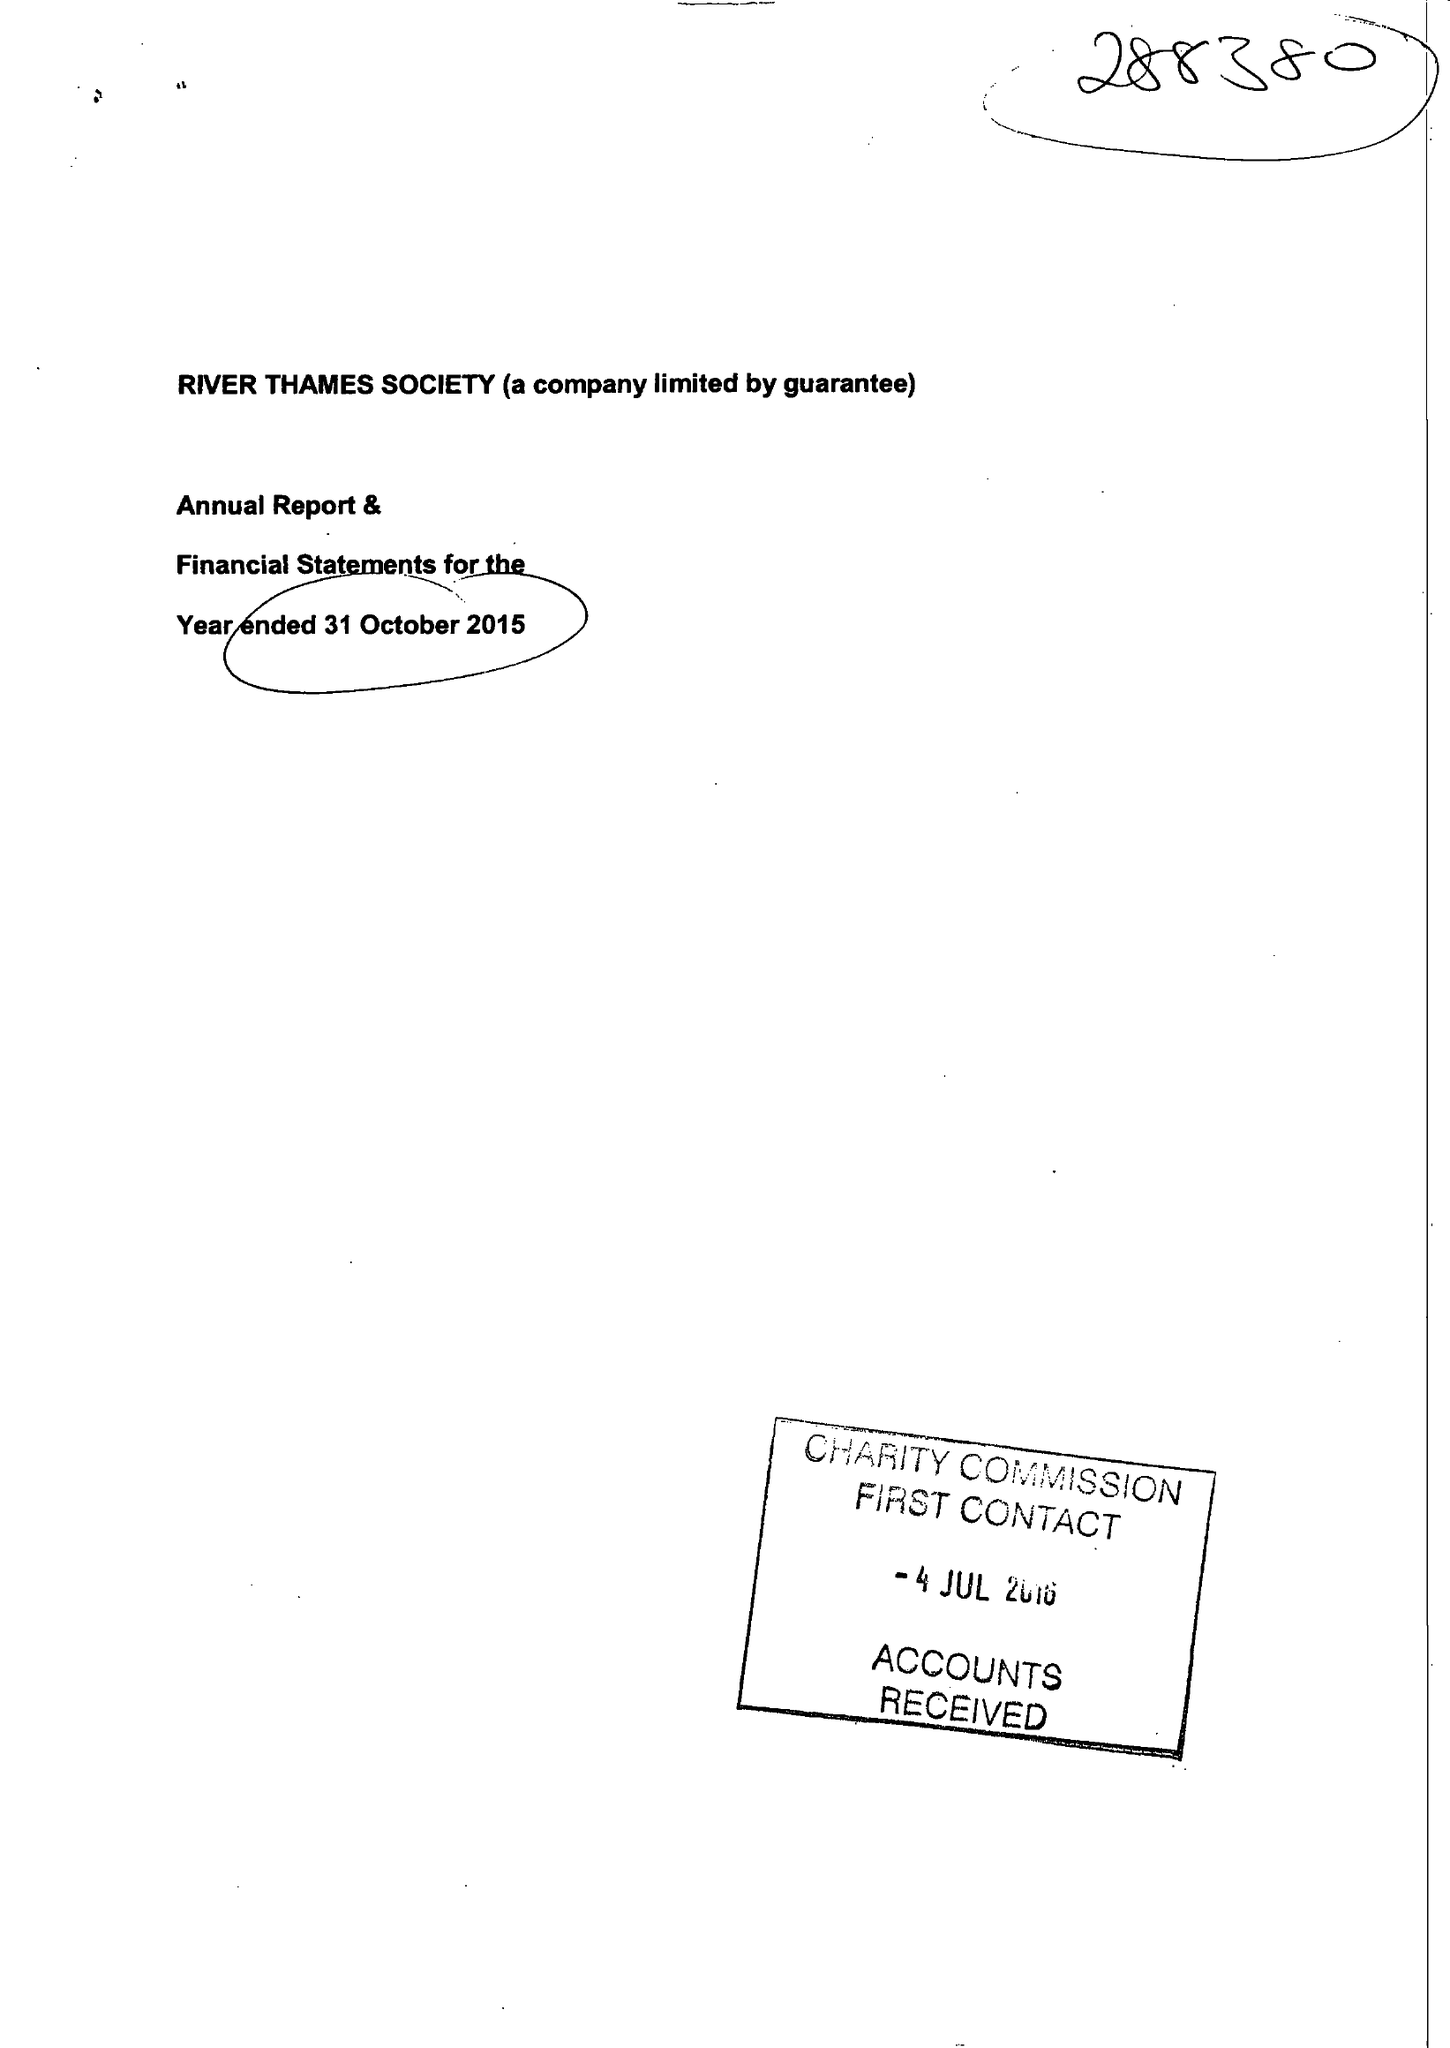What is the value for the charity_number?
Answer the question using a single word or phrase. 288380 